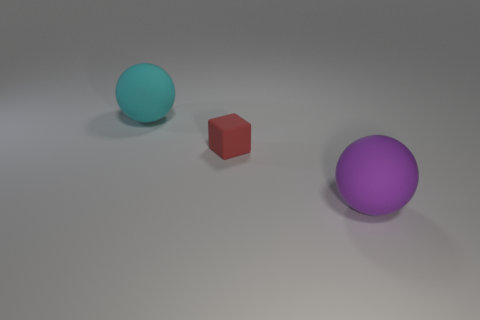Are there any other things that have the same size as the red object?
Offer a very short reply. No. There is a cyan thing that is made of the same material as the small block; what size is it?
Provide a succinct answer. Large. Are there more large yellow metallic objects than tiny red rubber cubes?
Your response must be concise. No. The large sphere right of the big cyan sphere is what color?
Make the answer very short. Purple. There is a rubber thing that is both on the left side of the purple sphere and on the right side of the large cyan matte sphere; how big is it?
Ensure brevity in your answer.  Small. How many cyan rubber balls are the same size as the red rubber cube?
Make the answer very short. 0. There is a large cyan object that is the same shape as the purple object; what is its material?
Provide a succinct answer. Rubber. Does the big purple rubber thing have the same shape as the cyan matte object?
Your response must be concise. Yes. What number of cyan objects are in front of the purple ball?
Ensure brevity in your answer.  0. There is a big rubber object that is on the left side of the big matte thing in front of the cyan thing; what is its shape?
Ensure brevity in your answer.  Sphere. 